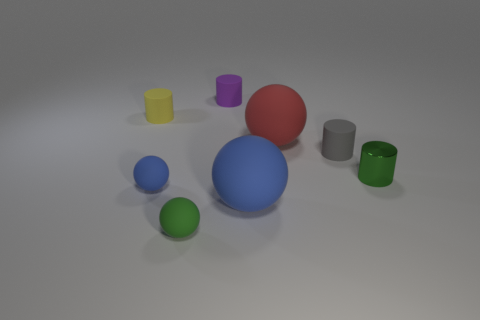Subtract 2 balls. How many balls are left? 2 Add 2 small cyan matte objects. How many objects exist? 10 Subtract all brown cylinders. Subtract all brown spheres. How many cylinders are left? 4 Add 5 yellow matte cylinders. How many yellow matte cylinders exist? 6 Subtract 0 brown cylinders. How many objects are left? 8 Subtract all small green matte balls. Subtract all yellow rubber cylinders. How many objects are left? 6 Add 1 big rubber spheres. How many big rubber spheres are left? 3 